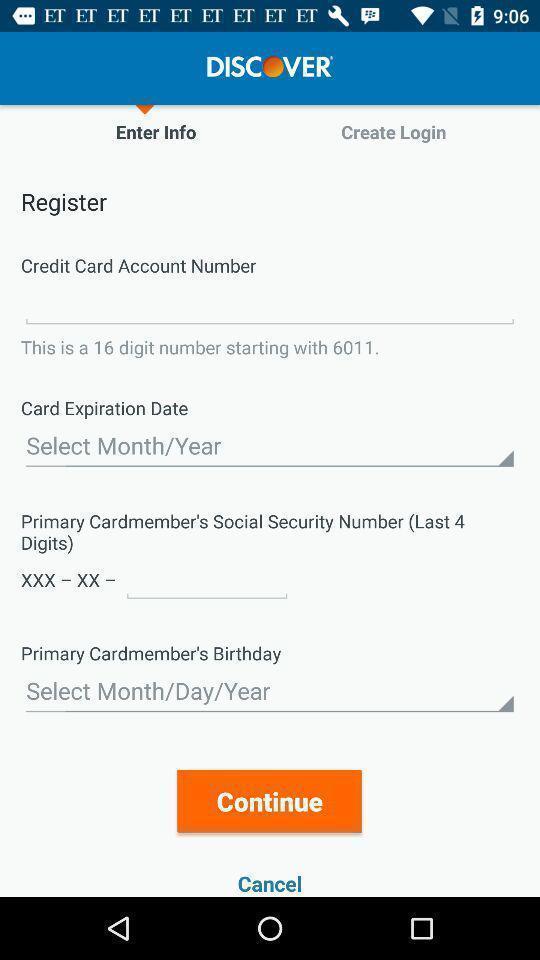Give me a narrative description of this picture. Registration page to register in discover. 